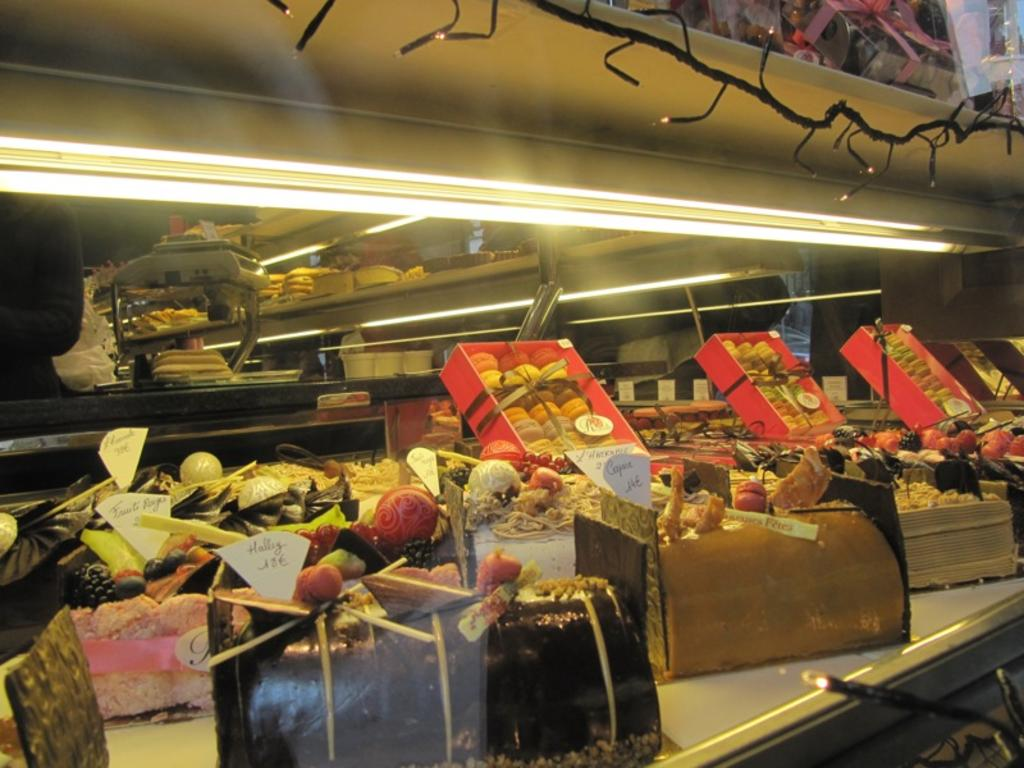What type of refrigerator is visible in the image? There is a glass refrigerator in the image. What items can be found inside the glass refrigerator? There are biscuits and chocolate in the glass refrigerator. Is there any additional storage in the glass refrigerator? Yes, there is a basket in the glass refrigerator. What can be seen in the image besides the glass refrigerator? There are decorative lights in the image. How does the refrigerator draw attention to itself in the image? The refrigerator does not actively draw attention to itself in the image; it is simply a part of the scene. 